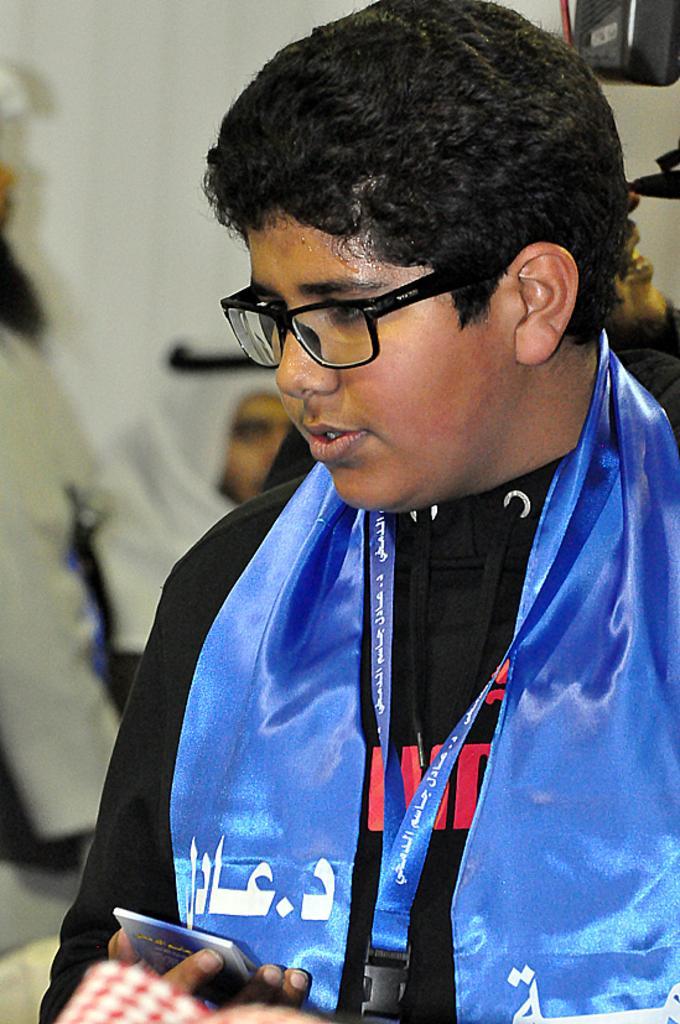Please provide a concise description of this image. In this image we can see there is a boy wearing black T-shirt and holding an object. 